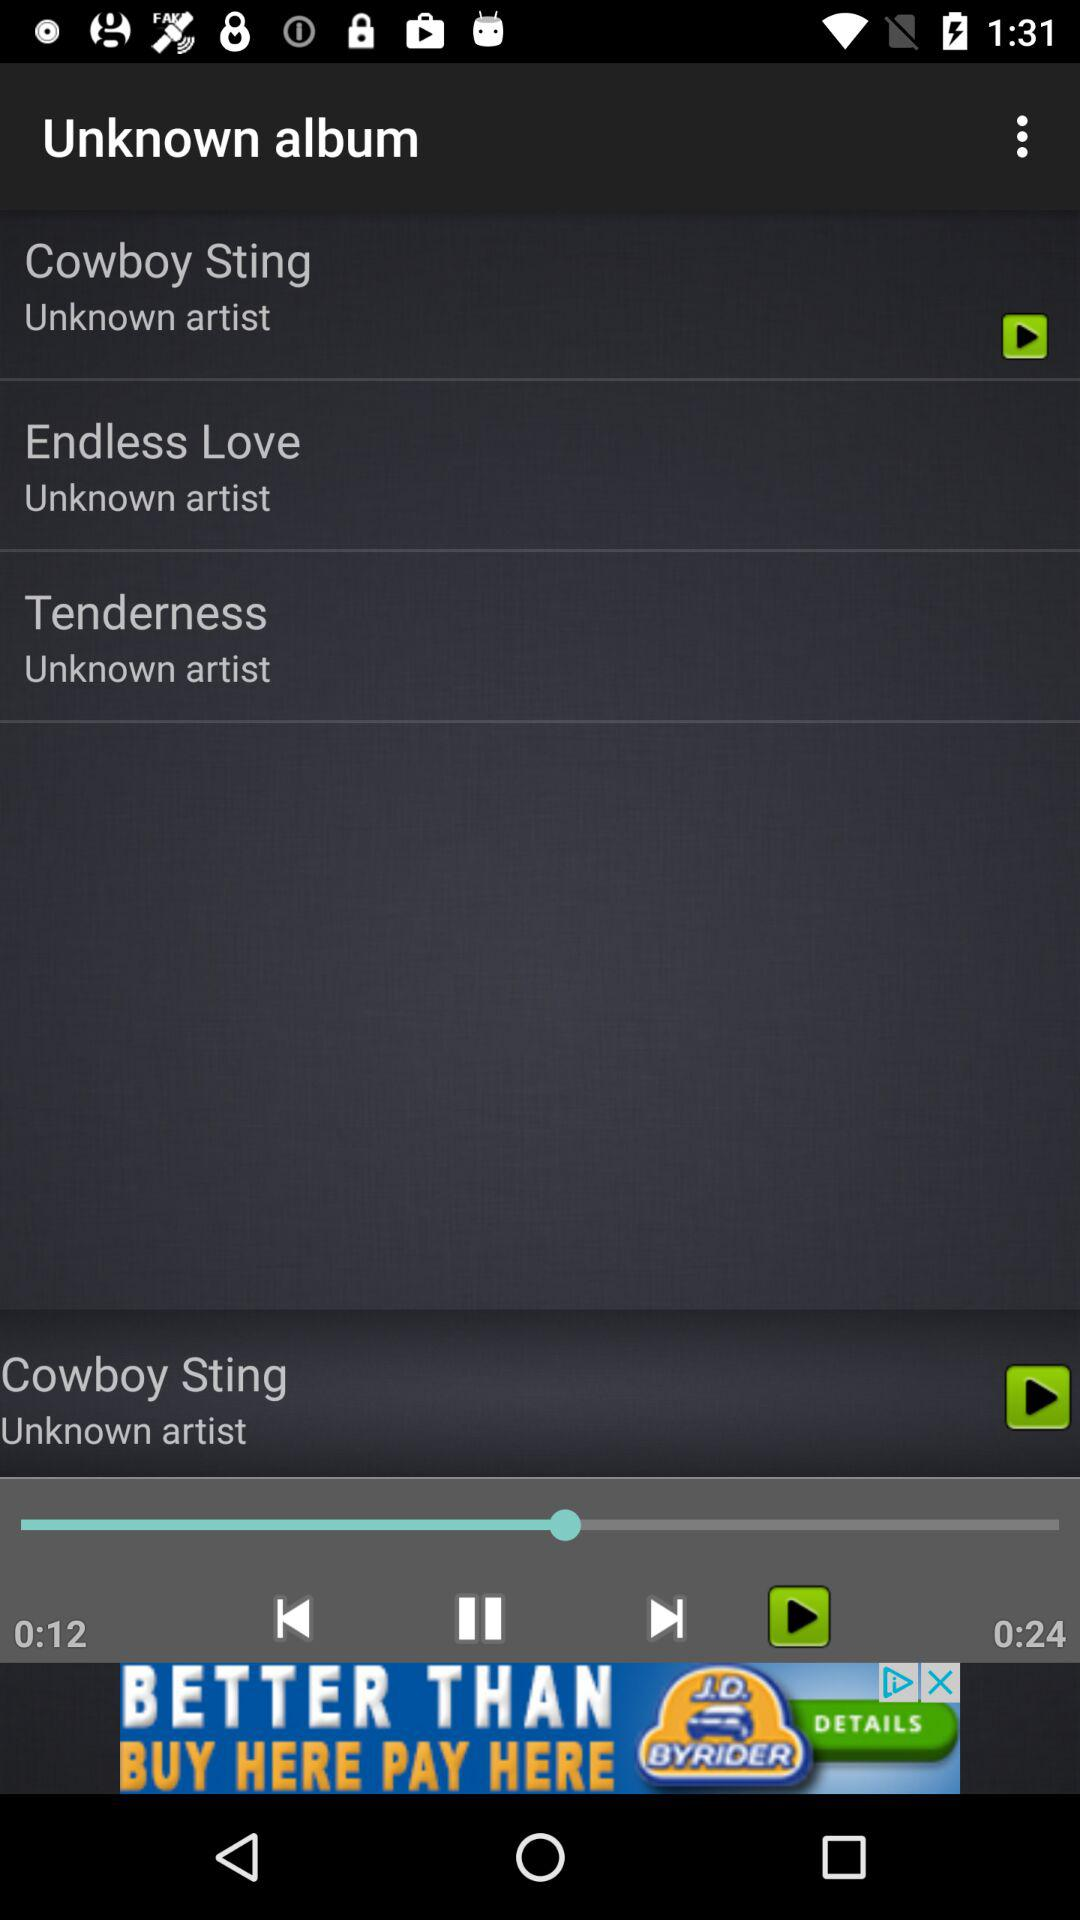What is the duration of the audio that is currently playing? The duration of the audio that is currently playing is 24 seconds. 